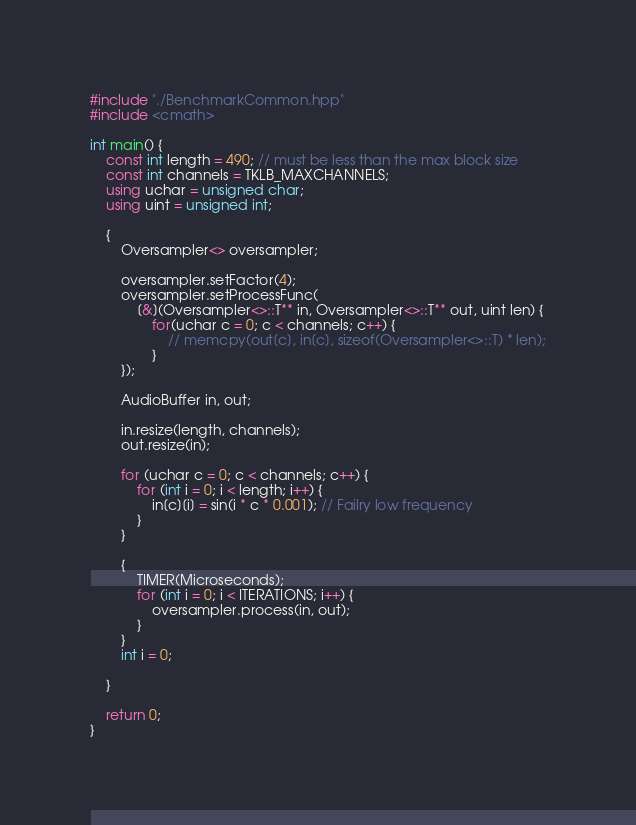<code> <loc_0><loc_0><loc_500><loc_500><_C++_>
#include "./BenchmarkCommon.hpp"
#include <cmath>

int main() {
	const int length = 490; // must be less than the max block size
	const int channels = TKLB_MAXCHANNELS;
	using uchar = unsigned char;
	using uint = unsigned int;

	{
		Oversampler<> oversampler;

		oversampler.setFactor(4);
		oversampler.setProcessFunc(
			[&](Oversampler<>::T** in, Oversampler<>::T** out, uint len) {
				for(uchar c = 0; c < channels; c++) {
					// memcpy(out[c], in[c], sizeof(Oversampler<>::T) * len);
				}
		});

		AudioBuffer in, out;

		in.resize(length, channels);
		out.resize(in);

		for (uchar c = 0; c < channels; c++) {
			for (int i = 0; i < length; i++) {
				in[c][i] = sin(i * c * 0.001); // Failry low frequency
			}
		}

		{
			TIMER(Microseconds);
			for (int i = 0; i < ITERATIONS; i++) {
				oversampler.process(in, out);
			}
		}
		int i = 0;

	}

	return 0;
}
</code> 